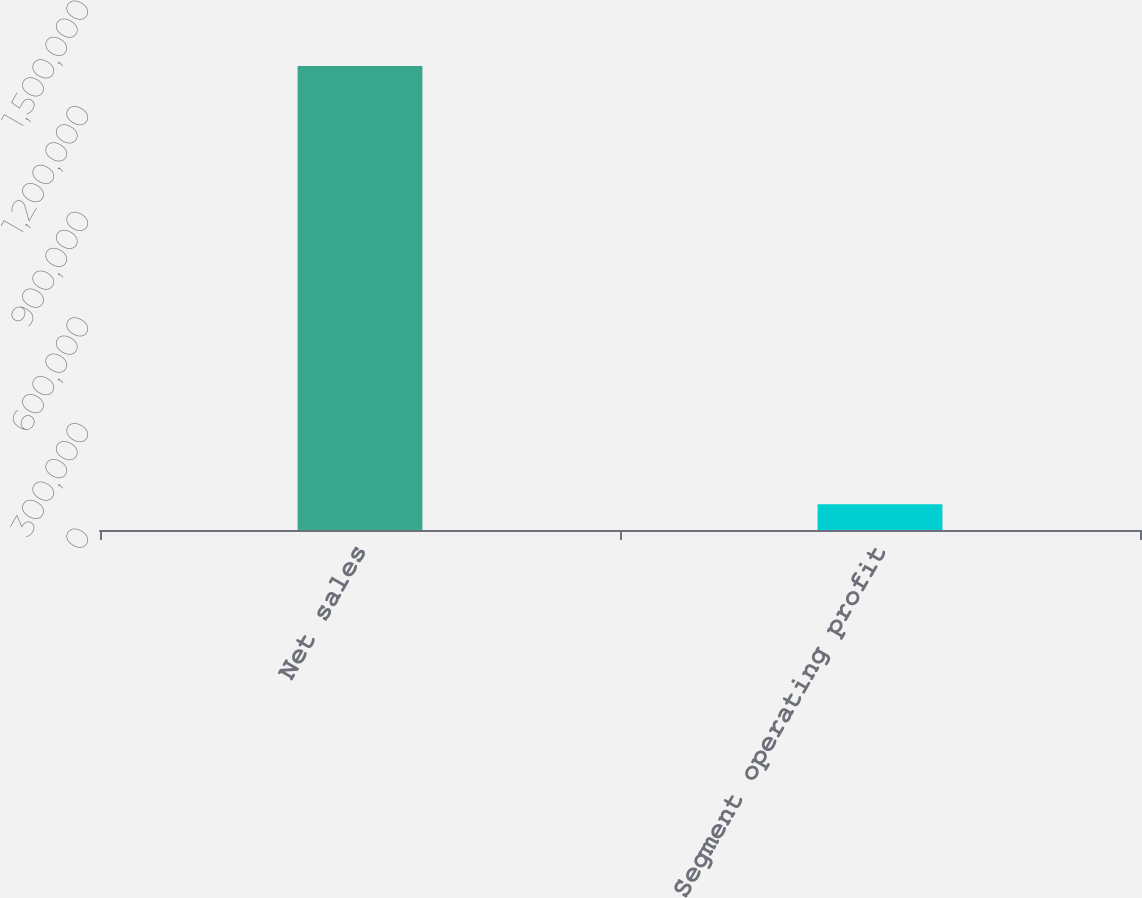<chart> <loc_0><loc_0><loc_500><loc_500><bar_chart><fcel>Net sales<fcel>Segment operating profit<nl><fcel>1.31801e+06<fcel>72820<nl></chart> 